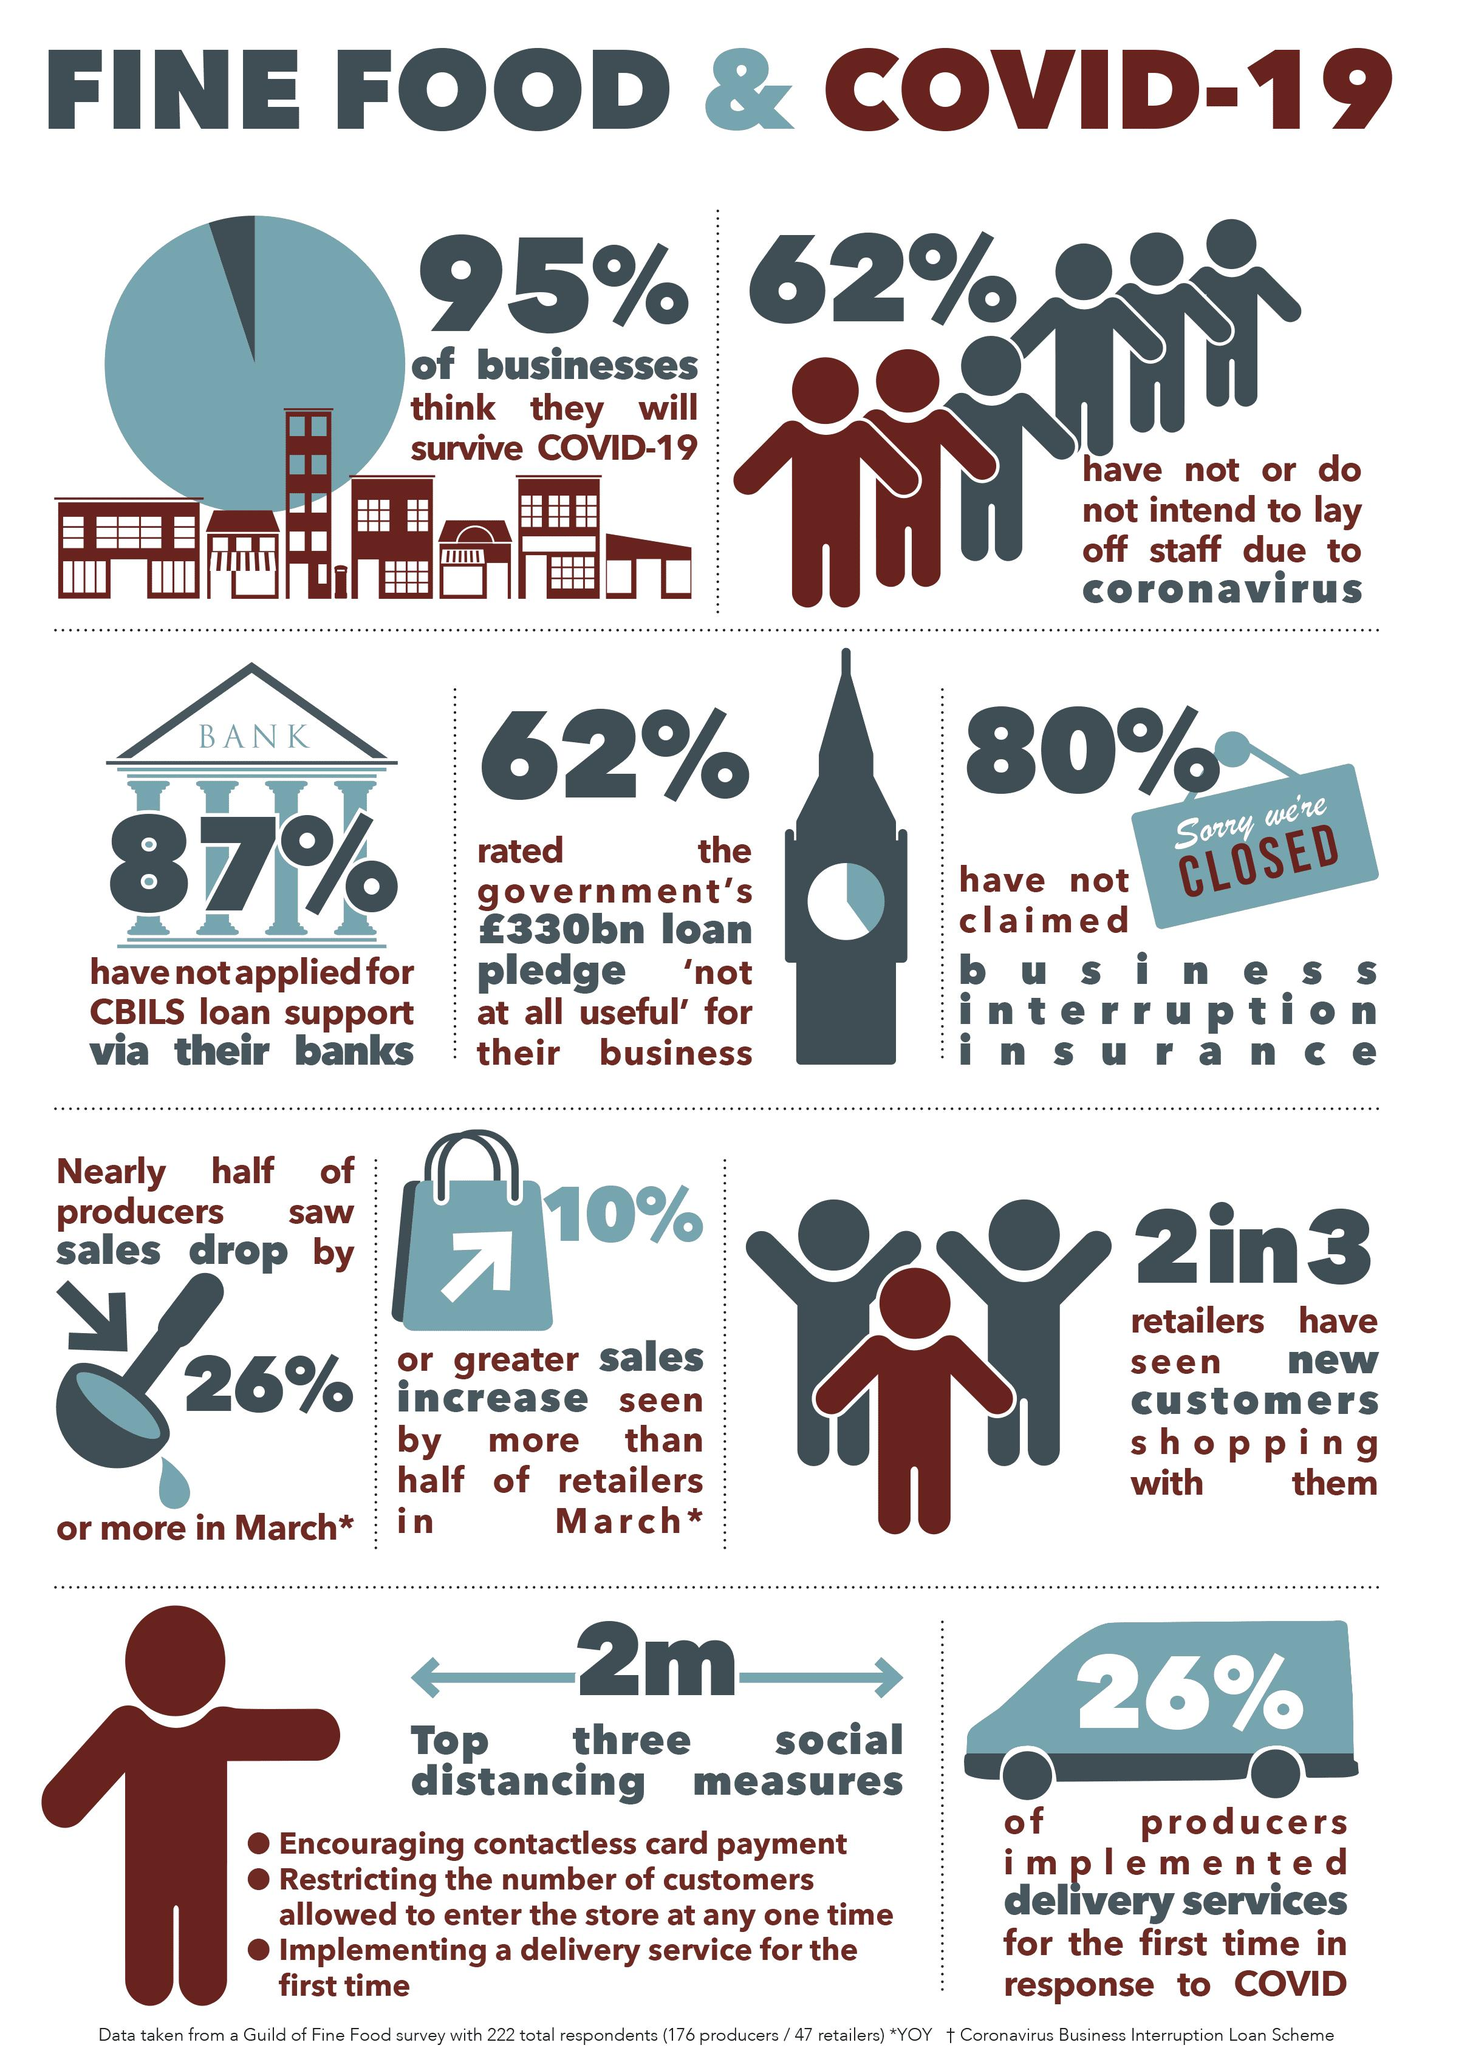Identify some key points in this picture. A recent survey indicates that a small percentage of businesses, estimated to be 5%, believe that they will not survive the pandemic caused by the COVID-19 virus. In response to the COVID-19 pandemic, 26% of producers implemented delivery services for the first time. According to a recent survey, approximately 20% of businesses have claimed business interruption insurance. According to a recent study, 87% of businesses have not applied for the CBILS loan support provided by their banks. According to a recent survey, 62% of businesses do not plan to lay off staff due to the ongoing COVID-19 pandemic. 